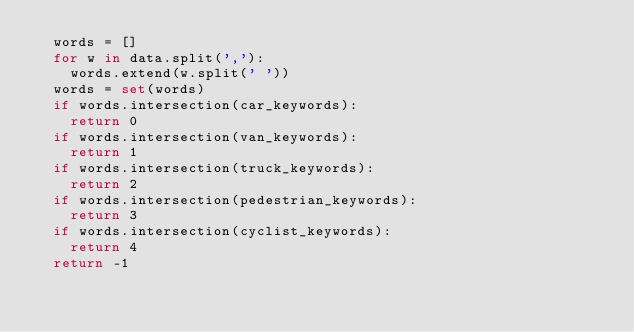Convert code to text. <code><loc_0><loc_0><loc_500><loc_500><_Python_>	words = []
	for w in data.split(','):
		words.extend(w.split(' '))
	words = set(words)
	if words.intersection(car_keywords):
		return 0
	if words.intersection(van_keywords):
		return 1
	if words.intersection(truck_keywords):
		return 2
	if words.intersection(pedestrian_keywords):
		return 3
	if words.intersection(cyclist_keywords):
		return 4
	return -1

</code> 